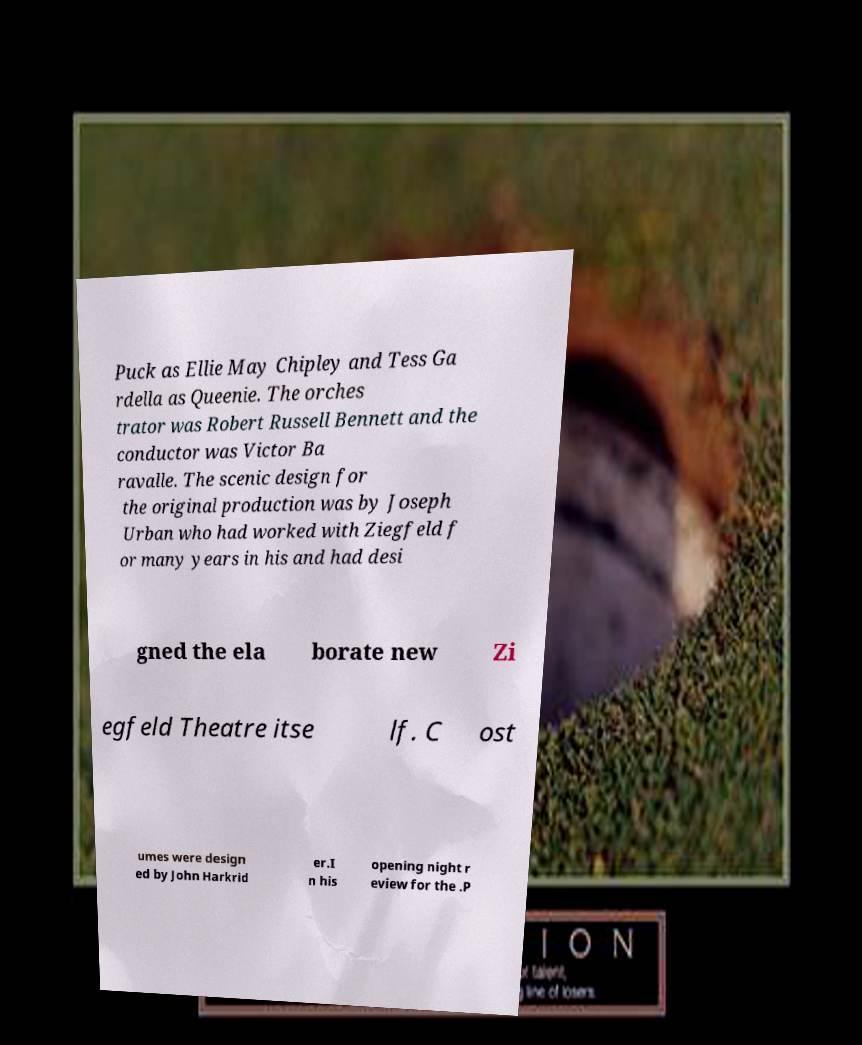I need the written content from this picture converted into text. Can you do that? Puck as Ellie May Chipley and Tess Ga rdella as Queenie. The orches trator was Robert Russell Bennett and the conductor was Victor Ba ravalle. The scenic design for the original production was by Joseph Urban who had worked with Ziegfeld f or many years in his and had desi gned the ela borate new Zi egfeld Theatre itse lf. C ost umes were design ed by John Harkrid er.I n his opening night r eview for the .P 